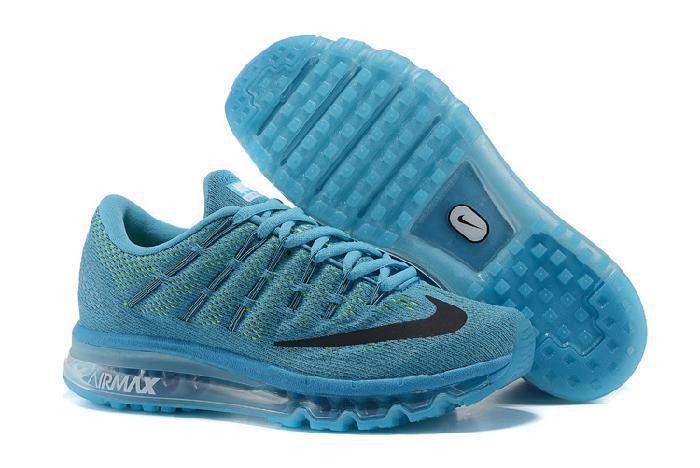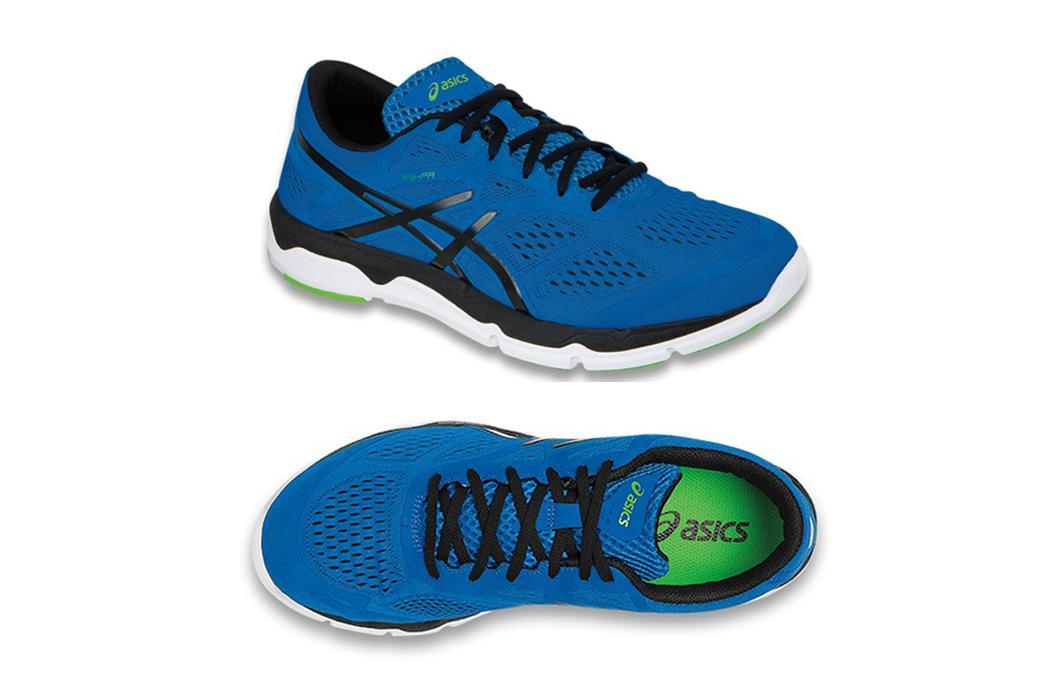The first image is the image on the left, the second image is the image on the right. Examine the images to the left and right. Is the description "There are fewer than four shoes depicted." accurate? Answer yes or no. No. The first image is the image on the left, the second image is the image on the right. For the images shown, is this caption "The left image contains a single right-facing blue sneaker, and the right image includes a shoe sole facing the camera." true? Answer yes or no. No. 